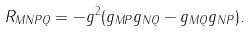<formula> <loc_0><loc_0><loc_500><loc_500>R _ { M N P Q } = - g ^ { 2 } ( g _ { M P } g _ { N Q } - g _ { M Q } g _ { N P } ) .</formula> 